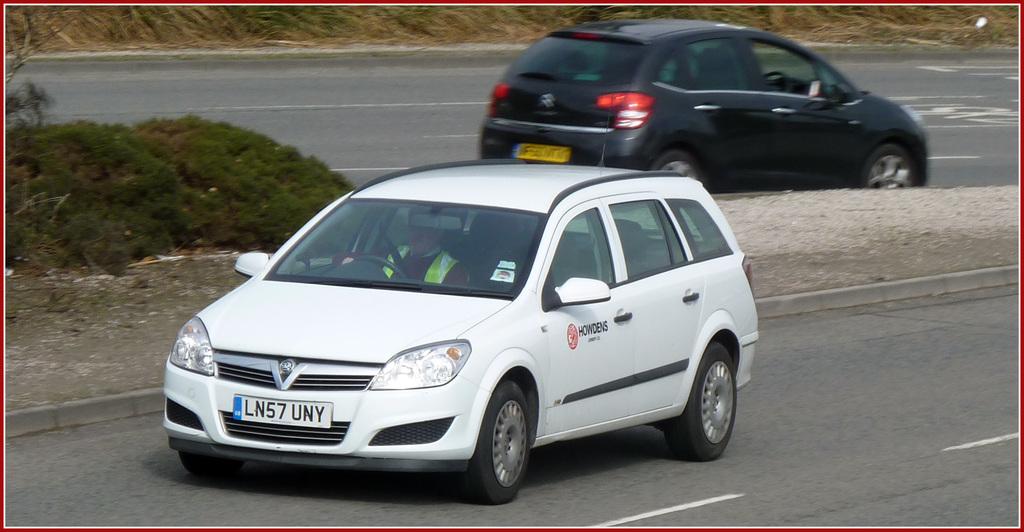What is the license plate of this car?
Provide a short and direct response. Ln57 uny. What is the license number on the white car?
Ensure brevity in your answer.  Ln57uny. 